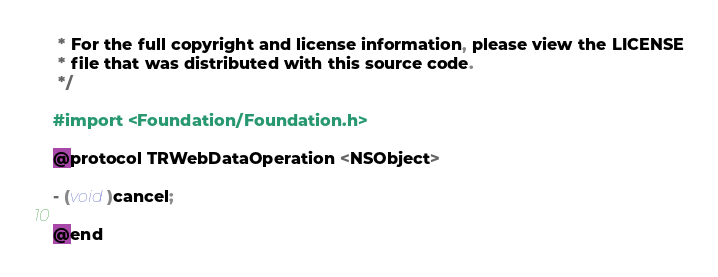<code> <loc_0><loc_0><loc_500><loc_500><_C_> * For the full copyright and license information, please view the LICENSE
 * file that was distributed with this source code.
 */

#import <Foundation/Foundation.h>

@protocol TRWebDataOperation <NSObject>

- (void)cancel;

@end
</code> 